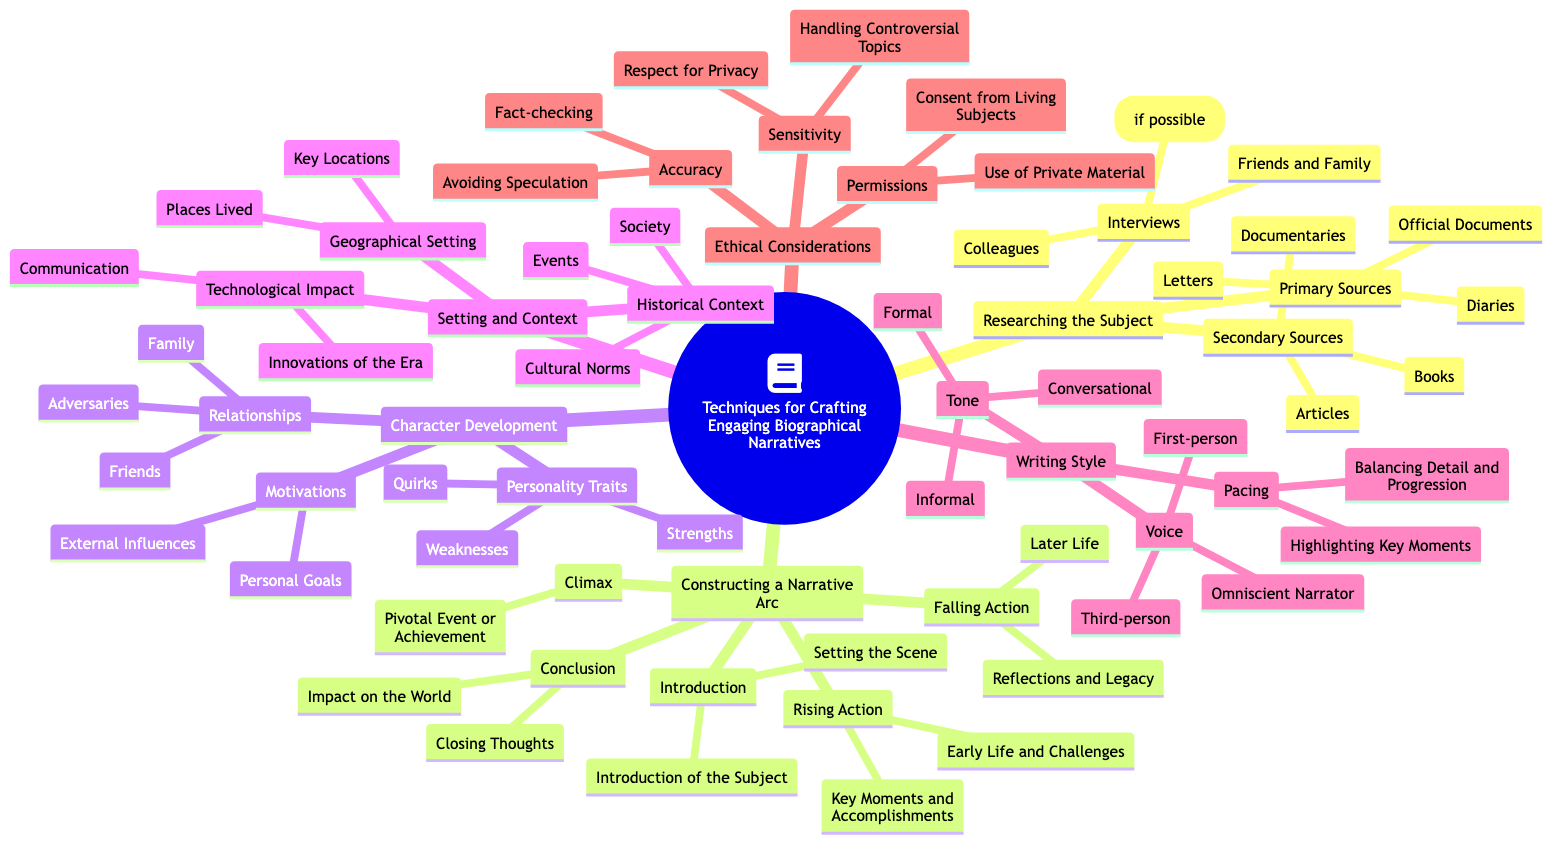What are three types of primary sources mentioned? The diagram lists three primary sources under "Researching the Subject." These include "Letters," "Diaries," and "Official Documents."
Answer: Letters, Diaries, Official Documents How many sections are there under "Constructing a Narrative Arc"? The "Constructing a Narrative Arc" section has five parts: "Introduction," "Rising Action," "Climax," "Falling Action," and "Conclusion."
Answer: 5 What is one personality trait type listed under "Character Development"? The diagram specifies "Strengths," "Weaknesses," and "Quirks" under "Personality Traits" in the "Character Development" section.
Answer: Strengths Under "Setting and Context," what subcategory references societal influences? The "Historical Context" subcategory includes "Cultural Norms," which refers to the societal influences at the time.
Answer: Cultural Norms Which writing style voice is not mentioned in the mind map? The diagram lists "First-person," "Third-person," and "Omniscient Narrator" under "Voice" in the "Writing Style" section, but does not mention "Second-person."
Answer: Second-person What is the last item listed in the "Ethical Considerations" section? The last item under "Ethical Considerations" is "Use of Private Material," found under "Permissions."
Answer: Use of Private Material How are the components of "Rising Action" categorized? "Rising Action" consists of "Early Life and Challenges" and "Key Moments and Accomplishments," both of which highlight significant life events.
Answer: Early Life and Challenges, Key Moments and Accomplishments What is the focus of the "Climax" section? The "Climax" section is focused on the "Pivotal Event or Achievement," indicating a critical moment in the subject's life.
Answer: Pivotal Event or Achievement 